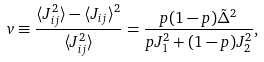Convert formula to latex. <formula><loc_0><loc_0><loc_500><loc_500>v \equiv \frac { \langle J _ { i j } ^ { 2 } \rangle - \langle J _ { i j } \rangle ^ { 2 } } { \langle J _ { i j } ^ { 2 } \rangle } = \frac { p ( 1 - p ) \tilde { \Delta } ^ { 2 } } { p J _ { 1 } ^ { 2 } + ( 1 - p ) J _ { 2 } ^ { 2 } } ,</formula> 